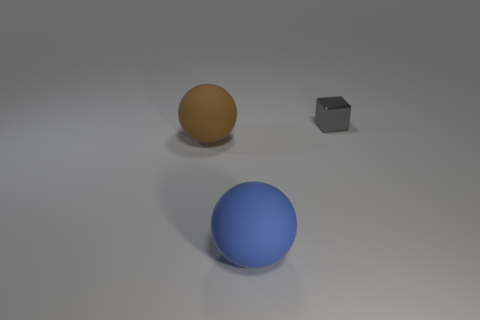What number of other objects are there of the same material as the big blue object?
Provide a short and direct response. 1. What is the size of the object that is both in front of the small thing and behind the blue ball?
Provide a succinct answer. Large. The big object in front of the brown thing that is on the left side of the large blue rubber ball is what shape?
Provide a succinct answer. Sphere. Is there anything else that is the same shape as the gray metallic object?
Provide a succinct answer. No. Are there an equal number of large blue rubber objects that are to the right of the tiny gray shiny thing and large brown rubber things?
Your answer should be compact. No. There is a metal object; does it have the same color as the rubber ball that is behind the large blue matte object?
Offer a very short reply. No. What is the color of the thing that is both behind the big blue sphere and in front of the tiny gray metal block?
Provide a short and direct response. Brown. How many things are on the left side of the big rubber ball in front of the brown sphere?
Ensure brevity in your answer.  1. Is there another brown rubber thing of the same shape as the big brown rubber thing?
Offer a terse response. No. There is a large rubber object that is in front of the brown object; does it have the same shape as the gray object that is right of the brown ball?
Offer a terse response. No. 